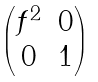<formula> <loc_0><loc_0><loc_500><loc_500>\begin{pmatrix} f ^ { 2 } & 0 \\ 0 & 1 \end{pmatrix}</formula> 